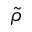<formula> <loc_0><loc_0><loc_500><loc_500>\tilde { \rho }</formula> 